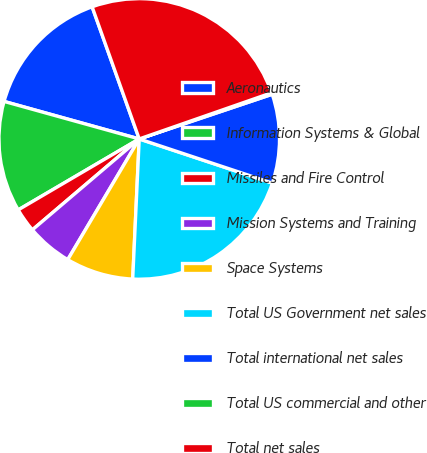Convert chart to OTSL. <chart><loc_0><loc_0><loc_500><loc_500><pie_chart><fcel>Aeronautics<fcel>Information Systems & Global<fcel>Missiles and Fire Control<fcel>Mission Systems and Training<fcel>Space Systems<fcel>Total US Government net sales<fcel>Total international net sales<fcel>Total US commercial and other<fcel>Total net sales<nl><fcel>15.24%<fcel>12.75%<fcel>2.78%<fcel>5.27%<fcel>7.77%<fcel>20.64%<fcel>10.26%<fcel>0.18%<fcel>25.11%<nl></chart> 